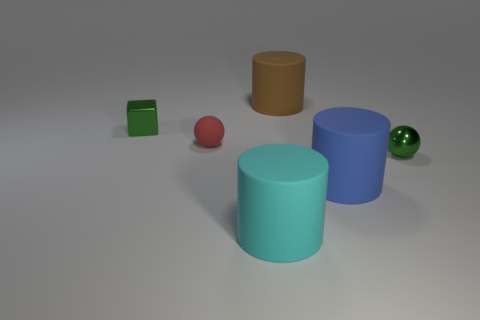There is a metal object that is the same color as the tiny metal cube; what is its size?
Provide a short and direct response. Small. What is the material of the green thing in front of the small green metallic cube?
Give a very brief answer. Metal. Are there fewer cylinders than large cyan cylinders?
Offer a terse response. No. What is the shape of the big blue matte object?
Offer a terse response. Cylinder. Do the big matte object that is behind the red matte thing and the metal sphere have the same color?
Your answer should be very brief. No. There is a large object that is in front of the red ball and behind the cyan rubber thing; what is its shape?
Provide a succinct answer. Cylinder. What is the color of the cylinder on the left side of the large brown matte object?
Offer a terse response. Cyan. Is there anything else that has the same color as the tiny matte object?
Ensure brevity in your answer.  No. Does the blue object have the same size as the red rubber ball?
Offer a very short reply. No. What size is the thing that is both behind the blue object and to the right of the large brown thing?
Offer a terse response. Small. 